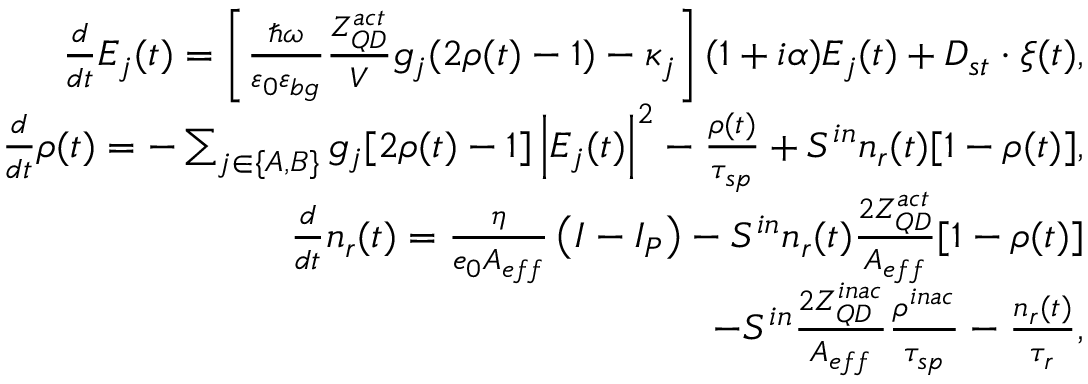Convert formula to latex. <formula><loc_0><loc_0><loc_500><loc_500>\begin{array} { r } { \frac { d } { d t } E _ { j } ( t ) = \left [ \frac { \hbar { \omega } } { \varepsilon _ { 0 } \varepsilon _ { b g } } \frac { Z _ { Q D } ^ { a c t } } { V } g _ { j } ( 2 \rho ( t ) - 1 ) - \kappa _ { j } \right ] ( 1 + i \alpha ) E _ { j } ( t ) + D _ { s t } \cdot \xi ( t ) , } \\ { \frac { d } { d t } \rho ( t ) = - \sum _ { j \in \{ A , B \} } g _ { j } [ 2 \rho ( t ) - 1 ] \left | E _ { j } ( t ) \right | ^ { 2 } - \frac { \rho ( t ) } { \tau _ { s p } } + S ^ { i n } n _ { r } ( t ) [ 1 - \rho ( t ) ] , } \\ { \frac { d } { d t } n _ { r } ( t ) = \frac { \eta } { e _ { 0 } A _ { e f f } } \left ( I - I _ { P } \right ) - S ^ { i n } n _ { r } ( t ) \frac { 2 Z _ { Q D } ^ { a c t } } { A _ { e f f } } [ 1 - \rho ( t ) ] } \\ { - S ^ { i n } \frac { 2 Z _ { Q D } ^ { i n a c } } { A _ { e f f } } \frac { \rho ^ { i n a c } } { \tau _ { s p } } - \frac { n _ { r } ( t ) } { \tau _ { r } } , } \end{array}</formula> 